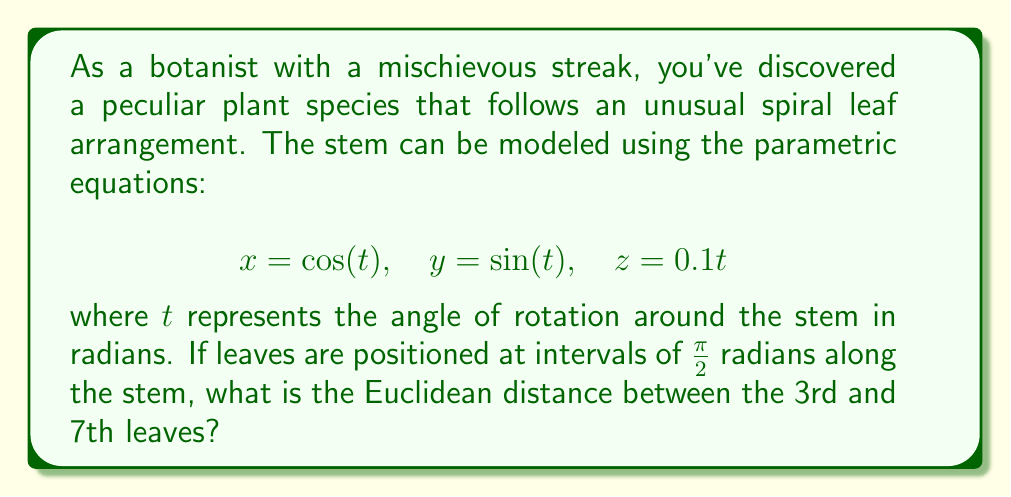Give your solution to this math problem. Let's approach this step-by-step:

1) First, we need to determine the positions of the 3rd and 7th leaves.
   - 3rd leaf: $t_3 = 3 \cdot \frac{\pi}{2} = \frac{3\pi}{2}$
   - 7th leaf: $t_7 = 7 \cdot \frac{\pi}{2} = \frac{7\pi}{2}$

2) Now, let's calculate the coordinates for each leaf:

   3rd leaf:
   $$x_3 = \cos(\frac{3\pi}{2}) = 0$$
   $$y_3 = \sin(\frac{3\pi}{2}) = -1$$
   $$z_3 = 0.1 \cdot \frac{3\pi}{2} = 0.15\pi$$

   7th leaf:
   $$x_7 = \cos(\frac{7\pi}{2}) = 0$$
   $$y_7 = \sin(\frac{7\pi}{2}) = 1$$
   $$z_7 = 0.1 \cdot \frac{7\pi}{2} = 0.35\pi$$

3) The Euclidean distance between two points $(x_1, y_1, z_1)$ and $(x_2, y_2, z_2)$ is given by:
   $$d = \sqrt{(x_2-x_1)^2 + (y_2-y_1)^2 + (z_2-z_1)^2}$$

4) Plugging in our values:
   $$d = \sqrt{(0-0)^2 + (1-(-1))^2 + (0.35\pi-0.15\pi)^2}$$

5) Simplify:
   $$d = \sqrt{0^2 + 2^2 + (0.2\pi)^2}$$
   $$d = \sqrt{4 + 0.04\pi^2}$$

6) This cannot be simplified further without approximation.
Answer: The Euclidean distance between the 3rd and 7th leaves is $\sqrt{4 + 0.04\pi^2}$ units. 